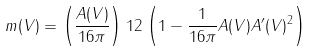Convert formula to latex. <formula><loc_0><loc_0><loc_500><loc_500>m ( V ) = \left ( \frac { A ( V ) } { 1 6 \pi } \right ) ^ { } { 1 } 2 \left ( 1 - \frac { 1 } { 1 6 \pi } A ( V ) A ^ { \prime } ( V ) ^ { 2 } \right )</formula> 